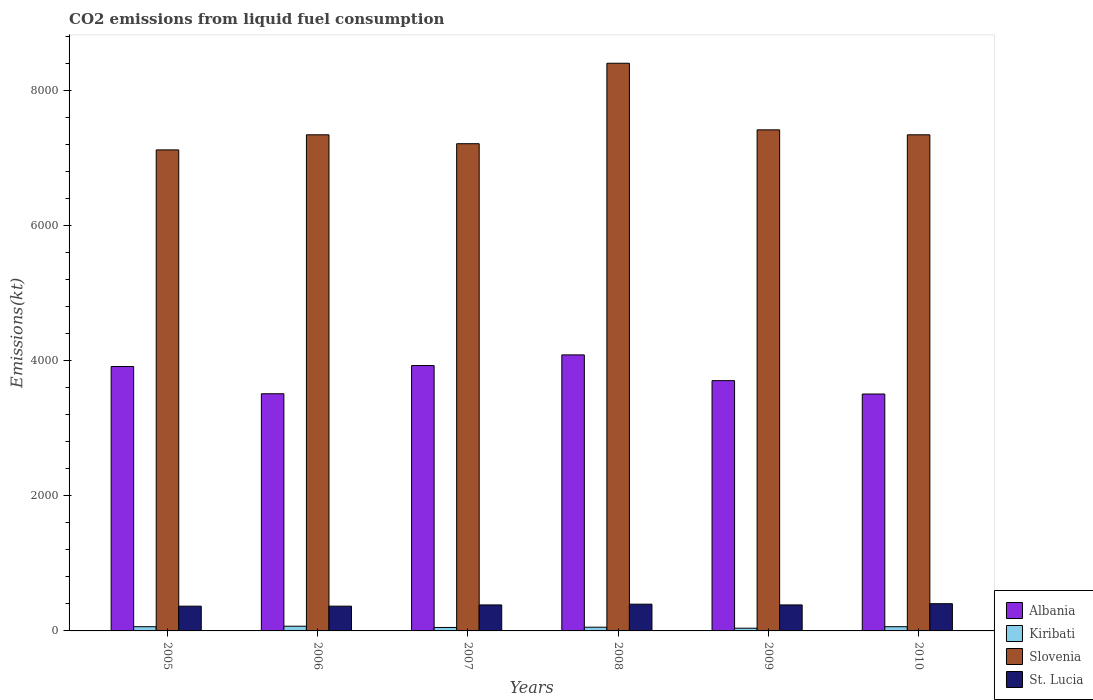How many different coloured bars are there?
Ensure brevity in your answer.  4. How many bars are there on the 4th tick from the left?
Provide a succinct answer. 4. What is the amount of CO2 emitted in Albania in 2010?
Ensure brevity in your answer.  3509.32. Across all years, what is the maximum amount of CO2 emitted in Kiribati?
Keep it short and to the point. 69.67. Across all years, what is the minimum amount of CO2 emitted in Slovenia?
Your response must be concise. 7124.98. In which year was the amount of CO2 emitted in Kiribati maximum?
Make the answer very short. 2006. What is the total amount of CO2 emitted in Albania in the graph?
Keep it short and to the point. 2.27e+04. What is the difference between the amount of CO2 emitted in Kiribati in 2008 and the amount of CO2 emitted in Albania in 2009?
Keep it short and to the point. -3652.33. What is the average amount of CO2 emitted in St. Lucia per year?
Your answer should be very brief. 383.81. In the year 2008, what is the difference between the amount of CO2 emitted in Albania and amount of CO2 emitted in St. Lucia?
Your response must be concise. 3692.67. In how many years, is the amount of CO2 emitted in Kiribati greater than 7200 kt?
Your response must be concise. 0. What is the ratio of the amount of CO2 emitted in Albania in 2006 to that in 2007?
Your response must be concise. 0.89. Is the amount of CO2 emitted in St. Lucia in 2006 less than that in 2007?
Keep it short and to the point. Yes. Is the difference between the amount of CO2 emitted in Albania in 2005 and 2007 greater than the difference between the amount of CO2 emitted in St. Lucia in 2005 and 2007?
Provide a short and direct response. Yes. What is the difference between the highest and the second highest amount of CO2 emitted in Kiribati?
Your response must be concise. 7.33. What is the difference between the highest and the lowest amount of CO2 emitted in St. Lucia?
Offer a very short reply. 36.67. What does the 2nd bar from the left in 2007 represents?
Your response must be concise. Kiribati. What does the 2nd bar from the right in 2009 represents?
Your response must be concise. Slovenia. Where does the legend appear in the graph?
Offer a terse response. Bottom right. How many legend labels are there?
Your response must be concise. 4. What is the title of the graph?
Your answer should be compact. CO2 emissions from liquid fuel consumption. Does "Indonesia" appear as one of the legend labels in the graph?
Make the answer very short. No. What is the label or title of the Y-axis?
Your response must be concise. Emissions(kt). What is the Emissions(kt) of Albania in 2005?
Provide a short and direct response. 3916.36. What is the Emissions(kt) of Kiribati in 2005?
Your response must be concise. 62.34. What is the Emissions(kt) of Slovenia in 2005?
Keep it short and to the point. 7124.98. What is the Emissions(kt) in St. Lucia in 2005?
Ensure brevity in your answer.  366.7. What is the Emissions(kt) in Albania in 2006?
Ensure brevity in your answer.  3512.99. What is the Emissions(kt) in Kiribati in 2006?
Offer a very short reply. 69.67. What is the Emissions(kt) in Slovenia in 2006?
Your answer should be compact. 7348.67. What is the Emissions(kt) in St. Lucia in 2006?
Keep it short and to the point. 366.7. What is the Emissions(kt) of Albania in 2007?
Ensure brevity in your answer.  3931.02. What is the Emissions(kt) of Kiribati in 2007?
Give a very brief answer. 51.34. What is the Emissions(kt) of Slovenia in 2007?
Offer a terse response. 7216.66. What is the Emissions(kt) of St. Lucia in 2007?
Give a very brief answer. 385.04. What is the Emissions(kt) in Albania in 2008?
Your answer should be very brief. 4088.7. What is the Emissions(kt) of Kiribati in 2008?
Ensure brevity in your answer.  55.01. What is the Emissions(kt) in Slovenia in 2008?
Your answer should be compact. 8408.43. What is the Emissions(kt) in St. Lucia in 2008?
Your response must be concise. 396.04. What is the Emissions(kt) in Albania in 2009?
Ensure brevity in your answer.  3707.34. What is the Emissions(kt) of Kiribati in 2009?
Give a very brief answer. 40.34. What is the Emissions(kt) of Slovenia in 2009?
Ensure brevity in your answer.  7422.01. What is the Emissions(kt) of St. Lucia in 2009?
Make the answer very short. 385.04. What is the Emissions(kt) in Albania in 2010?
Your answer should be very brief. 3509.32. What is the Emissions(kt) in Kiribati in 2010?
Give a very brief answer. 62.34. What is the Emissions(kt) of Slovenia in 2010?
Offer a very short reply. 7348.67. What is the Emissions(kt) in St. Lucia in 2010?
Your response must be concise. 403.37. Across all years, what is the maximum Emissions(kt) of Albania?
Offer a very short reply. 4088.7. Across all years, what is the maximum Emissions(kt) in Kiribati?
Your answer should be compact. 69.67. Across all years, what is the maximum Emissions(kt) in Slovenia?
Your response must be concise. 8408.43. Across all years, what is the maximum Emissions(kt) in St. Lucia?
Your response must be concise. 403.37. Across all years, what is the minimum Emissions(kt) of Albania?
Your answer should be compact. 3509.32. Across all years, what is the minimum Emissions(kt) in Kiribati?
Make the answer very short. 40.34. Across all years, what is the minimum Emissions(kt) of Slovenia?
Make the answer very short. 7124.98. Across all years, what is the minimum Emissions(kt) of St. Lucia?
Make the answer very short. 366.7. What is the total Emissions(kt) in Albania in the graph?
Keep it short and to the point. 2.27e+04. What is the total Emissions(kt) in Kiribati in the graph?
Your answer should be compact. 341.03. What is the total Emissions(kt) in Slovenia in the graph?
Make the answer very short. 4.49e+04. What is the total Emissions(kt) of St. Lucia in the graph?
Offer a very short reply. 2302.88. What is the difference between the Emissions(kt) of Albania in 2005 and that in 2006?
Keep it short and to the point. 403.37. What is the difference between the Emissions(kt) in Kiribati in 2005 and that in 2006?
Make the answer very short. -7.33. What is the difference between the Emissions(kt) in Slovenia in 2005 and that in 2006?
Provide a succinct answer. -223.69. What is the difference between the Emissions(kt) in Albania in 2005 and that in 2007?
Provide a short and direct response. -14.67. What is the difference between the Emissions(kt) in Kiribati in 2005 and that in 2007?
Offer a terse response. 11. What is the difference between the Emissions(kt) in Slovenia in 2005 and that in 2007?
Provide a short and direct response. -91.67. What is the difference between the Emissions(kt) of St. Lucia in 2005 and that in 2007?
Keep it short and to the point. -18.34. What is the difference between the Emissions(kt) of Albania in 2005 and that in 2008?
Offer a very short reply. -172.35. What is the difference between the Emissions(kt) in Kiribati in 2005 and that in 2008?
Your response must be concise. 7.33. What is the difference between the Emissions(kt) in Slovenia in 2005 and that in 2008?
Ensure brevity in your answer.  -1283.45. What is the difference between the Emissions(kt) in St. Lucia in 2005 and that in 2008?
Your answer should be compact. -29.34. What is the difference between the Emissions(kt) of Albania in 2005 and that in 2009?
Provide a succinct answer. 209.02. What is the difference between the Emissions(kt) of Kiribati in 2005 and that in 2009?
Offer a terse response. 22. What is the difference between the Emissions(kt) of Slovenia in 2005 and that in 2009?
Your answer should be very brief. -297.03. What is the difference between the Emissions(kt) of St. Lucia in 2005 and that in 2009?
Keep it short and to the point. -18.34. What is the difference between the Emissions(kt) of Albania in 2005 and that in 2010?
Provide a succinct answer. 407.04. What is the difference between the Emissions(kt) in Slovenia in 2005 and that in 2010?
Provide a short and direct response. -223.69. What is the difference between the Emissions(kt) in St. Lucia in 2005 and that in 2010?
Offer a terse response. -36.67. What is the difference between the Emissions(kt) of Albania in 2006 and that in 2007?
Give a very brief answer. -418.04. What is the difference between the Emissions(kt) in Kiribati in 2006 and that in 2007?
Offer a terse response. 18.34. What is the difference between the Emissions(kt) in Slovenia in 2006 and that in 2007?
Provide a short and direct response. 132.01. What is the difference between the Emissions(kt) of St. Lucia in 2006 and that in 2007?
Offer a very short reply. -18.34. What is the difference between the Emissions(kt) in Albania in 2006 and that in 2008?
Your response must be concise. -575.72. What is the difference between the Emissions(kt) of Kiribati in 2006 and that in 2008?
Your answer should be very brief. 14.67. What is the difference between the Emissions(kt) in Slovenia in 2006 and that in 2008?
Ensure brevity in your answer.  -1059.76. What is the difference between the Emissions(kt) in St. Lucia in 2006 and that in 2008?
Provide a short and direct response. -29.34. What is the difference between the Emissions(kt) in Albania in 2006 and that in 2009?
Your response must be concise. -194.35. What is the difference between the Emissions(kt) in Kiribati in 2006 and that in 2009?
Provide a succinct answer. 29.34. What is the difference between the Emissions(kt) in Slovenia in 2006 and that in 2009?
Offer a terse response. -73.34. What is the difference between the Emissions(kt) in St. Lucia in 2006 and that in 2009?
Offer a very short reply. -18.34. What is the difference between the Emissions(kt) in Albania in 2006 and that in 2010?
Your response must be concise. 3.67. What is the difference between the Emissions(kt) of Kiribati in 2006 and that in 2010?
Offer a terse response. 7.33. What is the difference between the Emissions(kt) of St. Lucia in 2006 and that in 2010?
Your response must be concise. -36.67. What is the difference between the Emissions(kt) of Albania in 2007 and that in 2008?
Give a very brief answer. -157.68. What is the difference between the Emissions(kt) of Kiribati in 2007 and that in 2008?
Your answer should be compact. -3.67. What is the difference between the Emissions(kt) of Slovenia in 2007 and that in 2008?
Keep it short and to the point. -1191.78. What is the difference between the Emissions(kt) of St. Lucia in 2007 and that in 2008?
Offer a very short reply. -11. What is the difference between the Emissions(kt) in Albania in 2007 and that in 2009?
Keep it short and to the point. 223.69. What is the difference between the Emissions(kt) in Kiribati in 2007 and that in 2009?
Give a very brief answer. 11. What is the difference between the Emissions(kt) of Slovenia in 2007 and that in 2009?
Provide a short and direct response. -205.35. What is the difference between the Emissions(kt) in St. Lucia in 2007 and that in 2009?
Your answer should be very brief. 0. What is the difference between the Emissions(kt) in Albania in 2007 and that in 2010?
Your answer should be very brief. 421.7. What is the difference between the Emissions(kt) of Kiribati in 2007 and that in 2010?
Ensure brevity in your answer.  -11. What is the difference between the Emissions(kt) in Slovenia in 2007 and that in 2010?
Offer a very short reply. -132.01. What is the difference between the Emissions(kt) of St. Lucia in 2007 and that in 2010?
Offer a terse response. -18.34. What is the difference between the Emissions(kt) of Albania in 2008 and that in 2009?
Keep it short and to the point. 381.37. What is the difference between the Emissions(kt) of Kiribati in 2008 and that in 2009?
Your answer should be very brief. 14.67. What is the difference between the Emissions(kt) in Slovenia in 2008 and that in 2009?
Your answer should be very brief. 986.42. What is the difference between the Emissions(kt) of St. Lucia in 2008 and that in 2009?
Provide a succinct answer. 11. What is the difference between the Emissions(kt) in Albania in 2008 and that in 2010?
Your answer should be compact. 579.39. What is the difference between the Emissions(kt) of Kiribati in 2008 and that in 2010?
Ensure brevity in your answer.  -7.33. What is the difference between the Emissions(kt) of Slovenia in 2008 and that in 2010?
Provide a succinct answer. 1059.76. What is the difference between the Emissions(kt) in St. Lucia in 2008 and that in 2010?
Offer a terse response. -7.33. What is the difference between the Emissions(kt) in Albania in 2009 and that in 2010?
Provide a succinct answer. 198.02. What is the difference between the Emissions(kt) of Kiribati in 2009 and that in 2010?
Ensure brevity in your answer.  -22. What is the difference between the Emissions(kt) in Slovenia in 2009 and that in 2010?
Keep it short and to the point. 73.34. What is the difference between the Emissions(kt) of St. Lucia in 2009 and that in 2010?
Offer a very short reply. -18.34. What is the difference between the Emissions(kt) in Albania in 2005 and the Emissions(kt) in Kiribati in 2006?
Ensure brevity in your answer.  3846.68. What is the difference between the Emissions(kt) of Albania in 2005 and the Emissions(kt) of Slovenia in 2006?
Keep it short and to the point. -3432.31. What is the difference between the Emissions(kt) in Albania in 2005 and the Emissions(kt) in St. Lucia in 2006?
Offer a terse response. 3549.66. What is the difference between the Emissions(kt) in Kiribati in 2005 and the Emissions(kt) in Slovenia in 2006?
Ensure brevity in your answer.  -7286.33. What is the difference between the Emissions(kt) in Kiribati in 2005 and the Emissions(kt) in St. Lucia in 2006?
Your response must be concise. -304.36. What is the difference between the Emissions(kt) in Slovenia in 2005 and the Emissions(kt) in St. Lucia in 2006?
Make the answer very short. 6758.28. What is the difference between the Emissions(kt) of Albania in 2005 and the Emissions(kt) of Kiribati in 2007?
Give a very brief answer. 3865.02. What is the difference between the Emissions(kt) in Albania in 2005 and the Emissions(kt) in Slovenia in 2007?
Your answer should be very brief. -3300.3. What is the difference between the Emissions(kt) of Albania in 2005 and the Emissions(kt) of St. Lucia in 2007?
Your response must be concise. 3531.32. What is the difference between the Emissions(kt) of Kiribati in 2005 and the Emissions(kt) of Slovenia in 2007?
Make the answer very short. -7154.32. What is the difference between the Emissions(kt) of Kiribati in 2005 and the Emissions(kt) of St. Lucia in 2007?
Ensure brevity in your answer.  -322.7. What is the difference between the Emissions(kt) of Slovenia in 2005 and the Emissions(kt) of St. Lucia in 2007?
Provide a succinct answer. 6739.95. What is the difference between the Emissions(kt) in Albania in 2005 and the Emissions(kt) in Kiribati in 2008?
Provide a succinct answer. 3861.35. What is the difference between the Emissions(kt) in Albania in 2005 and the Emissions(kt) in Slovenia in 2008?
Your response must be concise. -4492.07. What is the difference between the Emissions(kt) in Albania in 2005 and the Emissions(kt) in St. Lucia in 2008?
Offer a very short reply. 3520.32. What is the difference between the Emissions(kt) of Kiribati in 2005 and the Emissions(kt) of Slovenia in 2008?
Ensure brevity in your answer.  -8346.09. What is the difference between the Emissions(kt) in Kiribati in 2005 and the Emissions(kt) in St. Lucia in 2008?
Make the answer very short. -333.7. What is the difference between the Emissions(kt) of Slovenia in 2005 and the Emissions(kt) of St. Lucia in 2008?
Provide a succinct answer. 6728.94. What is the difference between the Emissions(kt) in Albania in 2005 and the Emissions(kt) in Kiribati in 2009?
Your answer should be compact. 3876.02. What is the difference between the Emissions(kt) of Albania in 2005 and the Emissions(kt) of Slovenia in 2009?
Your answer should be compact. -3505.65. What is the difference between the Emissions(kt) in Albania in 2005 and the Emissions(kt) in St. Lucia in 2009?
Your answer should be very brief. 3531.32. What is the difference between the Emissions(kt) of Kiribati in 2005 and the Emissions(kt) of Slovenia in 2009?
Offer a very short reply. -7359.67. What is the difference between the Emissions(kt) in Kiribati in 2005 and the Emissions(kt) in St. Lucia in 2009?
Provide a short and direct response. -322.7. What is the difference between the Emissions(kt) in Slovenia in 2005 and the Emissions(kt) in St. Lucia in 2009?
Make the answer very short. 6739.95. What is the difference between the Emissions(kt) of Albania in 2005 and the Emissions(kt) of Kiribati in 2010?
Offer a terse response. 3854.02. What is the difference between the Emissions(kt) in Albania in 2005 and the Emissions(kt) in Slovenia in 2010?
Offer a terse response. -3432.31. What is the difference between the Emissions(kt) of Albania in 2005 and the Emissions(kt) of St. Lucia in 2010?
Make the answer very short. 3512.99. What is the difference between the Emissions(kt) of Kiribati in 2005 and the Emissions(kt) of Slovenia in 2010?
Provide a short and direct response. -7286.33. What is the difference between the Emissions(kt) in Kiribati in 2005 and the Emissions(kt) in St. Lucia in 2010?
Offer a terse response. -341.03. What is the difference between the Emissions(kt) of Slovenia in 2005 and the Emissions(kt) of St. Lucia in 2010?
Offer a terse response. 6721.61. What is the difference between the Emissions(kt) in Albania in 2006 and the Emissions(kt) in Kiribati in 2007?
Give a very brief answer. 3461.65. What is the difference between the Emissions(kt) of Albania in 2006 and the Emissions(kt) of Slovenia in 2007?
Provide a short and direct response. -3703.67. What is the difference between the Emissions(kt) in Albania in 2006 and the Emissions(kt) in St. Lucia in 2007?
Offer a terse response. 3127.95. What is the difference between the Emissions(kt) of Kiribati in 2006 and the Emissions(kt) of Slovenia in 2007?
Offer a very short reply. -7146.98. What is the difference between the Emissions(kt) in Kiribati in 2006 and the Emissions(kt) in St. Lucia in 2007?
Offer a terse response. -315.36. What is the difference between the Emissions(kt) in Slovenia in 2006 and the Emissions(kt) in St. Lucia in 2007?
Make the answer very short. 6963.63. What is the difference between the Emissions(kt) in Albania in 2006 and the Emissions(kt) in Kiribati in 2008?
Offer a very short reply. 3457.98. What is the difference between the Emissions(kt) of Albania in 2006 and the Emissions(kt) of Slovenia in 2008?
Your answer should be very brief. -4895.44. What is the difference between the Emissions(kt) in Albania in 2006 and the Emissions(kt) in St. Lucia in 2008?
Your response must be concise. 3116.95. What is the difference between the Emissions(kt) of Kiribati in 2006 and the Emissions(kt) of Slovenia in 2008?
Make the answer very short. -8338.76. What is the difference between the Emissions(kt) of Kiribati in 2006 and the Emissions(kt) of St. Lucia in 2008?
Offer a very short reply. -326.36. What is the difference between the Emissions(kt) of Slovenia in 2006 and the Emissions(kt) of St. Lucia in 2008?
Your response must be concise. 6952.63. What is the difference between the Emissions(kt) of Albania in 2006 and the Emissions(kt) of Kiribati in 2009?
Your response must be concise. 3472.65. What is the difference between the Emissions(kt) in Albania in 2006 and the Emissions(kt) in Slovenia in 2009?
Your answer should be compact. -3909.02. What is the difference between the Emissions(kt) of Albania in 2006 and the Emissions(kt) of St. Lucia in 2009?
Your answer should be compact. 3127.95. What is the difference between the Emissions(kt) in Kiribati in 2006 and the Emissions(kt) in Slovenia in 2009?
Offer a terse response. -7352.34. What is the difference between the Emissions(kt) in Kiribati in 2006 and the Emissions(kt) in St. Lucia in 2009?
Give a very brief answer. -315.36. What is the difference between the Emissions(kt) of Slovenia in 2006 and the Emissions(kt) of St. Lucia in 2009?
Provide a succinct answer. 6963.63. What is the difference between the Emissions(kt) in Albania in 2006 and the Emissions(kt) in Kiribati in 2010?
Provide a succinct answer. 3450.65. What is the difference between the Emissions(kt) of Albania in 2006 and the Emissions(kt) of Slovenia in 2010?
Ensure brevity in your answer.  -3835.68. What is the difference between the Emissions(kt) of Albania in 2006 and the Emissions(kt) of St. Lucia in 2010?
Your answer should be very brief. 3109.62. What is the difference between the Emissions(kt) of Kiribati in 2006 and the Emissions(kt) of Slovenia in 2010?
Your answer should be compact. -7278.99. What is the difference between the Emissions(kt) in Kiribati in 2006 and the Emissions(kt) in St. Lucia in 2010?
Provide a short and direct response. -333.7. What is the difference between the Emissions(kt) of Slovenia in 2006 and the Emissions(kt) of St. Lucia in 2010?
Provide a succinct answer. 6945.3. What is the difference between the Emissions(kt) of Albania in 2007 and the Emissions(kt) of Kiribati in 2008?
Your response must be concise. 3876.02. What is the difference between the Emissions(kt) in Albania in 2007 and the Emissions(kt) in Slovenia in 2008?
Provide a succinct answer. -4477.41. What is the difference between the Emissions(kt) in Albania in 2007 and the Emissions(kt) in St. Lucia in 2008?
Your answer should be compact. 3534.99. What is the difference between the Emissions(kt) in Kiribati in 2007 and the Emissions(kt) in Slovenia in 2008?
Your answer should be compact. -8357.09. What is the difference between the Emissions(kt) in Kiribati in 2007 and the Emissions(kt) in St. Lucia in 2008?
Offer a terse response. -344.7. What is the difference between the Emissions(kt) in Slovenia in 2007 and the Emissions(kt) in St. Lucia in 2008?
Your response must be concise. 6820.62. What is the difference between the Emissions(kt) of Albania in 2007 and the Emissions(kt) of Kiribati in 2009?
Provide a short and direct response. 3890.69. What is the difference between the Emissions(kt) in Albania in 2007 and the Emissions(kt) in Slovenia in 2009?
Your answer should be very brief. -3490.98. What is the difference between the Emissions(kt) of Albania in 2007 and the Emissions(kt) of St. Lucia in 2009?
Your answer should be compact. 3545.99. What is the difference between the Emissions(kt) of Kiribati in 2007 and the Emissions(kt) of Slovenia in 2009?
Provide a short and direct response. -7370.67. What is the difference between the Emissions(kt) of Kiribati in 2007 and the Emissions(kt) of St. Lucia in 2009?
Offer a very short reply. -333.7. What is the difference between the Emissions(kt) in Slovenia in 2007 and the Emissions(kt) in St. Lucia in 2009?
Ensure brevity in your answer.  6831.62. What is the difference between the Emissions(kt) of Albania in 2007 and the Emissions(kt) of Kiribati in 2010?
Offer a terse response. 3868.68. What is the difference between the Emissions(kt) in Albania in 2007 and the Emissions(kt) in Slovenia in 2010?
Offer a very short reply. -3417.64. What is the difference between the Emissions(kt) in Albania in 2007 and the Emissions(kt) in St. Lucia in 2010?
Offer a very short reply. 3527.65. What is the difference between the Emissions(kt) in Kiribati in 2007 and the Emissions(kt) in Slovenia in 2010?
Provide a succinct answer. -7297.33. What is the difference between the Emissions(kt) in Kiribati in 2007 and the Emissions(kt) in St. Lucia in 2010?
Offer a terse response. -352.03. What is the difference between the Emissions(kt) of Slovenia in 2007 and the Emissions(kt) of St. Lucia in 2010?
Ensure brevity in your answer.  6813.29. What is the difference between the Emissions(kt) in Albania in 2008 and the Emissions(kt) in Kiribati in 2009?
Your answer should be very brief. 4048.37. What is the difference between the Emissions(kt) in Albania in 2008 and the Emissions(kt) in Slovenia in 2009?
Offer a very short reply. -3333.3. What is the difference between the Emissions(kt) in Albania in 2008 and the Emissions(kt) in St. Lucia in 2009?
Your response must be concise. 3703.67. What is the difference between the Emissions(kt) in Kiribati in 2008 and the Emissions(kt) in Slovenia in 2009?
Make the answer very short. -7367. What is the difference between the Emissions(kt) in Kiribati in 2008 and the Emissions(kt) in St. Lucia in 2009?
Your answer should be compact. -330.03. What is the difference between the Emissions(kt) of Slovenia in 2008 and the Emissions(kt) of St. Lucia in 2009?
Offer a very short reply. 8023.4. What is the difference between the Emissions(kt) of Albania in 2008 and the Emissions(kt) of Kiribati in 2010?
Provide a succinct answer. 4026.37. What is the difference between the Emissions(kt) in Albania in 2008 and the Emissions(kt) in Slovenia in 2010?
Your response must be concise. -3259.96. What is the difference between the Emissions(kt) of Albania in 2008 and the Emissions(kt) of St. Lucia in 2010?
Offer a very short reply. 3685.34. What is the difference between the Emissions(kt) in Kiribati in 2008 and the Emissions(kt) in Slovenia in 2010?
Your answer should be compact. -7293.66. What is the difference between the Emissions(kt) of Kiribati in 2008 and the Emissions(kt) of St. Lucia in 2010?
Your response must be concise. -348.37. What is the difference between the Emissions(kt) in Slovenia in 2008 and the Emissions(kt) in St. Lucia in 2010?
Your response must be concise. 8005.06. What is the difference between the Emissions(kt) in Albania in 2009 and the Emissions(kt) in Kiribati in 2010?
Make the answer very short. 3645. What is the difference between the Emissions(kt) of Albania in 2009 and the Emissions(kt) of Slovenia in 2010?
Ensure brevity in your answer.  -3641.33. What is the difference between the Emissions(kt) in Albania in 2009 and the Emissions(kt) in St. Lucia in 2010?
Ensure brevity in your answer.  3303.97. What is the difference between the Emissions(kt) of Kiribati in 2009 and the Emissions(kt) of Slovenia in 2010?
Your answer should be very brief. -7308.33. What is the difference between the Emissions(kt) in Kiribati in 2009 and the Emissions(kt) in St. Lucia in 2010?
Make the answer very short. -363.03. What is the difference between the Emissions(kt) in Slovenia in 2009 and the Emissions(kt) in St. Lucia in 2010?
Offer a very short reply. 7018.64. What is the average Emissions(kt) in Albania per year?
Make the answer very short. 3777.62. What is the average Emissions(kt) in Kiribati per year?
Provide a succinct answer. 56.84. What is the average Emissions(kt) in Slovenia per year?
Provide a short and direct response. 7478.24. What is the average Emissions(kt) of St. Lucia per year?
Provide a short and direct response. 383.81. In the year 2005, what is the difference between the Emissions(kt) in Albania and Emissions(kt) in Kiribati?
Keep it short and to the point. 3854.02. In the year 2005, what is the difference between the Emissions(kt) in Albania and Emissions(kt) in Slovenia?
Provide a short and direct response. -3208.62. In the year 2005, what is the difference between the Emissions(kt) in Albania and Emissions(kt) in St. Lucia?
Keep it short and to the point. 3549.66. In the year 2005, what is the difference between the Emissions(kt) of Kiribati and Emissions(kt) of Slovenia?
Keep it short and to the point. -7062.64. In the year 2005, what is the difference between the Emissions(kt) in Kiribati and Emissions(kt) in St. Lucia?
Provide a succinct answer. -304.36. In the year 2005, what is the difference between the Emissions(kt) of Slovenia and Emissions(kt) of St. Lucia?
Ensure brevity in your answer.  6758.28. In the year 2006, what is the difference between the Emissions(kt) in Albania and Emissions(kt) in Kiribati?
Offer a terse response. 3443.31. In the year 2006, what is the difference between the Emissions(kt) of Albania and Emissions(kt) of Slovenia?
Give a very brief answer. -3835.68. In the year 2006, what is the difference between the Emissions(kt) of Albania and Emissions(kt) of St. Lucia?
Your answer should be very brief. 3146.29. In the year 2006, what is the difference between the Emissions(kt) in Kiribati and Emissions(kt) in Slovenia?
Give a very brief answer. -7278.99. In the year 2006, what is the difference between the Emissions(kt) of Kiribati and Emissions(kt) of St. Lucia?
Offer a terse response. -297.03. In the year 2006, what is the difference between the Emissions(kt) of Slovenia and Emissions(kt) of St. Lucia?
Offer a terse response. 6981.97. In the year 2007, what is the difference between the Emissions(kt) in Albania and Emissions(kt) in Kiribati?
Offer a very short reply. 3879.69. In the year 2007, what is the difference between the Emissions(kt) in Albania and Emissions(kt) in Slovenia?
Provide a succinct answer. -3285.63. In the year 2007, what is the difference between the Emissions(kt) in Albania and Emissions(kt) in St. Lucia?
Keep it short and to the point. 3545.99. In the year 2007, what is the difference between the Emissions(kt) in Kiribati and Emissions(kt) in Slovenia?
Your answer should be compact. -7165.32. In the year 2007, what is the difference between the Emissions(kt) in Kiribati and Emissions(kt) in St. Lucia?
Your answer should be compact. -333.7. In the year 2007, what is the difference between the Emissions(kt) in Slovenia and Emissions(kt) in St. Lucia?
Offer a very short reply. 6831.62. In the year 2008, what is the difference between the Emissions(kt) of Albania and Emissions(kt) of Kiribati?
Give a very brief answer. 4033.7. In the year 2008, what is the difference between the Emissions(kt) in Albania and Emissions(kt) in Slovenia?
Your answer should be very brief. -4319.73. In the year 2008, what is the difference between the Emissions(kt) of Albania and Emissions(kt) of St. Lucia?
Your response must be concise. 3692.67. In the year 2008, what is the difference between the Emissions(kt) of Kiribati and Emissions(kt) of Slovenia?
Give a very brief answer. -8353.43. In the year 2008, what is the difference between the Emissions(kt) in Kiribati and Emissions(kt) in St. Lucia?
Your response must be concise. -341.03. In the year 2008, what is the difference between the Emissions(kt) of Slovenia and Emissions(kt) of St. Lucia?
Offer a terse response. 8012.4. In the year 2009, what is the difference between the Emissions(kt) in Albania and Emissions(kt) in Kiribati?
Provide a short and direct response. 3667. In the year 2009, what is the difference between the Emissions(kt) in Albania and Emissions(kt) in Slovenia?
Keep it short and to the point. -3714.67. In the year 2009, what is the difference between the Emissions(kt) in Albania and Emissions(kt) in St. Lucia?
Ensure brevity in your answer.  3322.3. In the year 2009, what is the difference between the Emissions(kt) in Kiribati and Emissions(kt) in Slovenia?
Your answer should be compact. -7381.67. In the year 2009, what is the difference between the Emissions(kt) of Kiribati and Emissions(kt) of St. Lucia?
Offer a very short reply. -344.7. In the year 2009, what is the difference between the Emissions(kt) of Slovenia and Emissions(kt) of St. Lucia?
Ensure brevity in your answer.  7036.97. In the year 2010, what is the difference between the Emissions(kt) of Albania and Emissions(kt) of Kiribati?
Offer a terse response. 3446.98. In the year 2010, what is the difference between the Emissions(kt) in Albania and Emissions(kt) in Slovenia?
Make the answer very short. -3839.35. In the year 2010, what is the difference between the Emissions(kt) of Albania and Emissions(kt) of St. Lucia?
Make the answer very short. 3105.95. In the year 2010, what is the difference between the Emissions(kt) of Kiribati and Emissions(kt) of Slovenia?
Your answer should be compact. -7286.33. In the year 2010, what is the difference between the Emissions(kt) in Kiribati and Emissions(kt) in St. Lucia?
Offer a terse response. -341.03. In the year 2010, what is the difference between the Emissions(kt) of Slovenia and Emissions(kt) of St. Lucia?
Your response must be concise. 6945.3. What is the ratio of the Emissions(kt) of Albania in 2005 to that in 2006?
Offer a terse response. 1.11. What is the ratio of the Emissions(kt) in Kiribati in 2005 to that in 2006?
Ensure brevity in your answer.  0.89. What is the ratio of the Emissions(kt) in Slovenia in 2005 to that in 2006?
Ensure brevity in your answer.  0.97. What is the ratio of the Emissions(kt) in St. Lucia in 2005 to that in 2006?
Offer a very short reply. 1. What is the ratio of the Emissions(kt) of Albania in 2005 to that in 2007?
Offer a very short reply. 1. What is the ratio of the Emissions(kt) of Kiribati in 2005 to that in 2007?
Provide a succinct answer. 1.21. What is the ratio of the Emissions(kt) in Slovenia in 2005 to that in 2007?
Provide a succinct answer. 0.99. What is the ratio of the Emissions(kt) of St. Lucia in 2005 to that in 2007?
Provide a succinct answer. 0.95. What is the ratio of the Emissions(kt) of Albania in 2005 to that in 2008?
Your response must be concise. 0.96. What is the ratio of the Emissions(kt) in Kiribati in 2005 to that in 2008?
Make the answer very short. 1.13. What is the ratio of the Emissions(kt) in Slovenia in 2005 to that in 2008?
Your answer should be compact. 0.85. What is the ratio of the Emissions(kt) of St. Lucia in 2005 to that in 2008?
Make the answer very short. 0.93. What is the ratio of the Emissions(kt) of Albania in 2005 to that in 2009?
Make the answer very short. 1.06. What is the ratio of the Emissions(kt) in Kiribati in 2005 to that in 2009?
Your response must be concise. 1.55. What is the ratio of the Emissions(kt) in Slovenia in 2005 to that in 2009?
Your answer should be compact. 0.96. What is the ratio of the Emissions(kt) in Albania in 2005 to that in 2010?
Make the answer very short. 1.12. What is the ratio of the Emissions(kt) in Kiribati in 2005 to that in 2010?
Provide a succinct answer. 1. What is the ratio of the Emissions(kt) in Slovenia in 2005 to that in 2010?
Make the answer very short. 0.97. What is the ratio of the Emissions(kt) in St. Lucia in 2005 to that in 2010?
Your answer should be compact. 0.91. What is the ratio of the Emissions(kt) of Albania in 2006 to that in 2007?
Ensure brevity in your answer.  0.89. What is the ratio of the Emissions(kt) in Kiribati in 2006 to that in 2007?
Your response must be concise. 1.36. What is the ratio of the Emissions(kt) in Slovenia in 2006 to that in 2007?
Give a very brief answer. 1.02. What is the ratio of the Emissions(kt) of Albania in 2006 to that in 2008?
Offer a terse response. 0.86. What is the ratio of the Emissions(kt) of Kiribati in 2006 to that in 2008?
Your answer should be very brief. 1.27. What is the ratio of the Emissions(kt) of Slovenia in 2006 to that in 2008?
Keep it short and to the point. 0.87. What is the ratio of the Emissions(kt) of St. Lucia in 2006 to that in 2008?
Give a very brief answer. 0.93. What is the ratio of the Emissions(kt) of Albania in 2006 to that in 2009?
Offer a terse response. 0.95. What is the ratio of the Emissions(kt) in Kiribati in 2006 to that in 2009?
Your answer should be very brief. 1.73. What is the ratio of the Emissions(kt) in Slovenia in 2006 to that in 2009?
Your response must be concise. 0.99. What is the ratio of the Emissions(kt) of Albania in 2006 to that in 2010?
Offer a terse response. 1. What is the ratio of the Emissions(kt) in Kiribati in 2006 to that in 2010?
Your answer should be compact. 1.12. What is the ratio of the Emissions(kt) of St. Lucia in 2006 to that in 2010?
Offer a terse response. 0.91. What is the ratio of the Emissions(kt) in Albania in 2007 to that in 2008?
Offer a very short reply. 0.96. What is the ratio of the Emissions(kt) in Kiribati in 2007 to that in 2008?
Make the answer very short. 0.93. What is the ratio of the Emissions(kt) of Slovenia in 2007 to that in 2008?
Give a very brief answer. 0.86. What is the ratio of the Emissions(kt) in St. Lucia in 2007 to that in 2008?
Keep it short and to the point. 0.97. What is the ratio of the Emissions(kt) of Albania in 2007 to that in 2009?
Your answer should be compact. 1.06. What is the ratio of the Emissions(kt) of Kiribati in 2007 to that in 2009?
Ensure brevity in your answer.  1.27. What is the ratio of the Emissions(kt) in Slovenia in 2007 to that in 2009?
Make the answer very short. 0.97. What is the ratio of the Emissions(kt) of St. Lucia in 2007 to that in 2009?
Your answer should be very brief. 1. What is the ratio of the Emissions(kt) in Albania in 2007 to that in 2010?
Make the answer very short. 1.12. What is the ratio of the Emissions(kt) in Kiribati in 2007 to that in 2010?
Offer a terse response. 0.82. What is the ratio of the Emissions(kt) of Slovenia in 2007 to that in 2010?
Offer a very short reply. 0.98. What is the ratio of the Emissions(kt) of St. Lucia in 2007 to that in 2010?
Your answer should be very brief. 0.95. What is the ratio of the Emissions(kt) in Albania in 2008 to that in 2009?
Ensure brevity in your answer.  1.1. What is the ratio of the Emissions(kt) of Kiribati in 2008 to that in 2009?
Your answer should be very brief. 1.36. What is the ratio of the Emissions(kt) of Slovenia in 2008 to that in 2009?
Offer a terse response. 1.13. What is the ratio of the Emissions(kt) in St. Lucia in 2008 to that in 2009?
Give a very brief answer. 1.03. What is the ratio of the Emissions(kt) of Albania in 2008 to that in 2010?
Provide a succinct answer. 1.17. What is the ratio of the Emissions(kt) of Kiribati in 2008 to that in 2010?
Give a very brief answer. 0.88. What is the ratio of the Emissions(kt) of Slovenia in 2008 to that in 2010?
Give a very brief answer. 1.14. What is the ratio of the Emissions(kt) of St. Lucia in 2008 to that in 2010?
Your response must be concise. 0.98. What is the ratio of the Emissions(kt) of Albania in 2009 to that in 2010?
Give a very brief answer. 1.06. What is the ratio of the Emissions(kt) of Kiribati in 2009 to that in 2010?
Offer a terse response. 0.65. What is the ratio of the Emissions(kt) in St. Lucia in 2009 to that in 2010?
Your answer should be compact. 0.95. What is the difference between the highest and the second highest Emissions(kt) of Albania?
Provide a succinct answer. 157.68. What is the difference between the highest and the second highest Emissions(kt) of Kiribati?
Provide a succinct answer. 7.33. What is the difference between the highest and the second highest Emissions(kt) of Slovenia?
Make the answer very short. 986.42. What is the difference between the highest and the second highest Emissions(kt) of St. Lucia?
Offer a very short reply. 7.33. What is the difference between the highest and the lowest Emissions(kt) in Albania?
Provide a succinct answer. 579.39. What is the difference between the highest and the lowest Emissions(kt) in Kiribati?
Your answer should be compact. 29.34. What is the difference between the highest and the lowest Emissions(kt) of Slovenia?
Make the answer very short. 1283.45. What is the difference between the highest and the lowest Emissions(kt) in St. Lucia?
Make the answer very short. 36.67. 